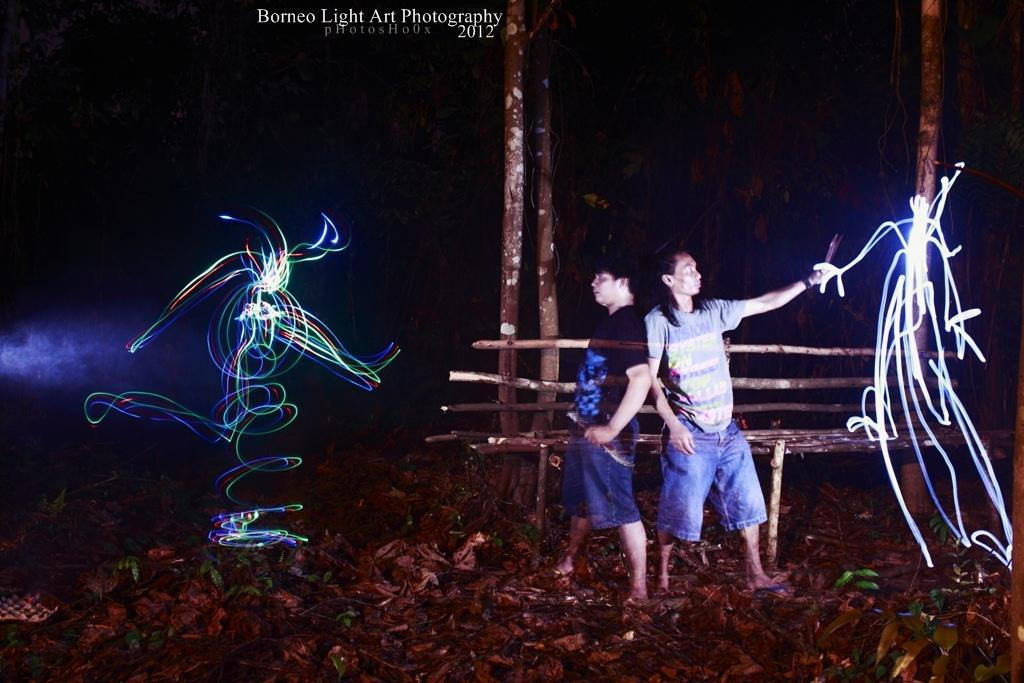How many people are in the image? There are two men in the middle of the image. What can be seen on either side of the image? There are lights on either side of the image. Is there any text or logo visible in the image? Yes, there is a watermark at the top of the image. Can you see any snow in the image? There is no snow present in the image. Is there a hole visible in the image? There is no hole visible in the image. 